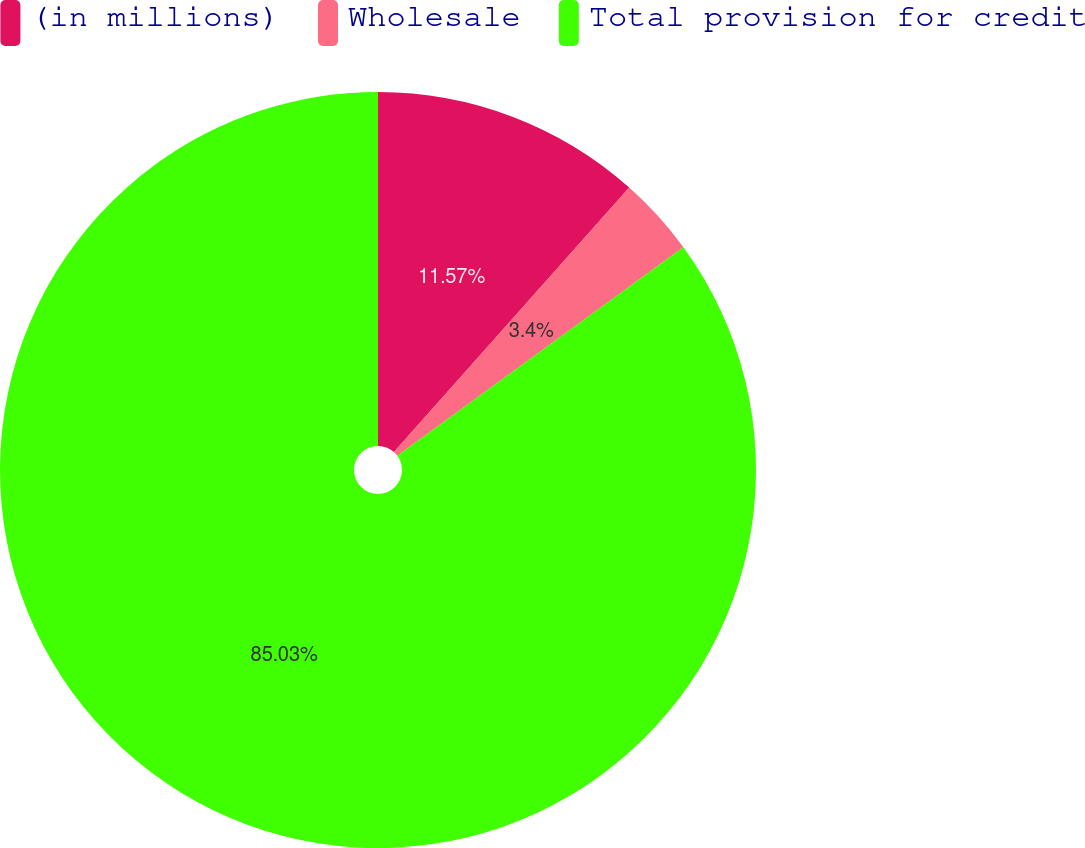<chart> <loc_0><loc_0><loc_500><loc_500><pie_chart><fcel>(in millions)<fcel>Wholesale<fcel>Total provision for credit<nl><fcel>11.57%<fcel>3.4%<fcel>85.03%<nl></chart> 